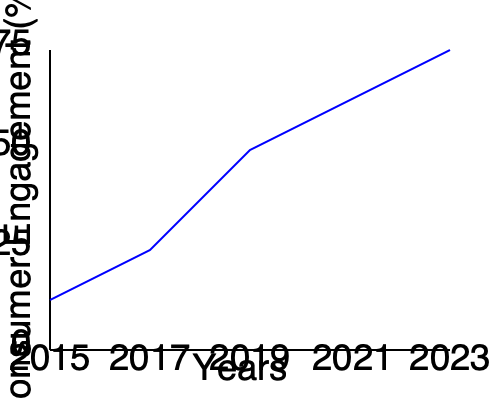As a marketing professional, you're analyzing the impact of social media on consumer behavior over the past decade. The graph shows the percentage of consumers actively engaging with brands on social media platforms from 2015 to 2023. What is the approximate percentage increase in consumer engagement from 2015 to 2023? To calculate the percentage increase in consumer engagement from 2015 to 2023, we need to follow these steps:

1. Identify the starting point (2015) and endpoint (2023) values:
   - 2015: approximately 25%
   - 2023: approximately 75%

2. Calculate the difference between the two values:
   $75\% - 25\% = 50\%$

3. To find the percentage increase, we use the formula:
   $\text{Percentage Increase} = \frac{\text{Increase}}{\text{Original Value}} \times 100\%$

4. Plug in the values:
   $\text{Percentage Increase} = \frac{50\%}{25\%} \times 100\% = 2 \times 100\% = 200\%$

Therefore, the approximate percentage increase in consumer engagement from 2015 to 2023 is 200%.

This significant increase reflects the growing importance of social media in consumer behavior, a trend that modern marketing professionals need to consider when bridging the gap between traditional marketing approaches and contemporary digital strategies.
Answer: 200% 